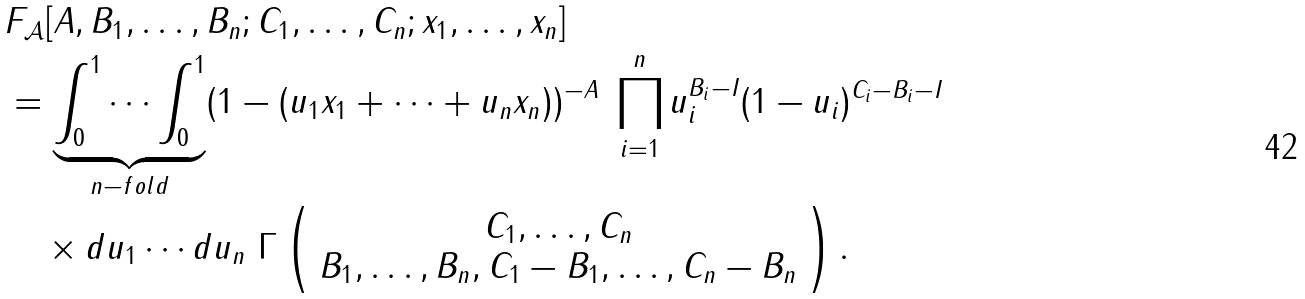<formula> <loc_0><loc_0><loc_500><loc_500>& F _ { \mathcal { A } } [ A , B _ { 1 } , \dots , B _ { n } ; C _ { 1 } , \dots , C _ { n } ; x _ { 1 } , \dots , x _ { n } ] \\ & = \underbrace { \int _ { 0 } ^ { 1 } \cdots \int _ { 0 } ^ { 1 } } _ { n - f o l d } ( 1 - ( u _ { 1 } x _ { 1 } + \cdots + u _ { n } x _ { n } ) ) ^ { - A } \ \prod _ { i = 1 } ^ { n } u _ { i } ^ { B _ { i } - I } ( 1 - u _ { i } ) ^ { C _ { i } - B _ { i } - I } \\ & \quad \times d u _ { 1 } \cdots d u _ { n } \ \Gamma \left ( \begin{array} { c } C _ { 1 } , \dots , C _ { n } \\ B _ { 1 } , \dots , B _ { n } , C _ { 1 } - B _ { 1 } , \dots , C _ { n } - B _ { n } \end{array} \right ) .</formula> 